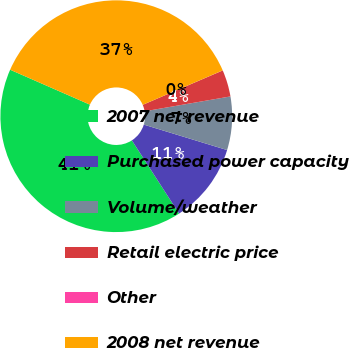Convert chart to OTSL. <chart><loc_0><loc_0><loc_500><loc_500><pie_chart><fcel>2007 net revenue<fcel>Purchased power capacity<fcel>Volume/weather<fcel>Retail electric price<fcel>Other<fcel>2008 net revenue<nl><fcel>40.69%<fcel>11.17%<fcel>7.45%<fcel>3.73%<fcel>0.01%<fcel>36.97%<nl></chart> 